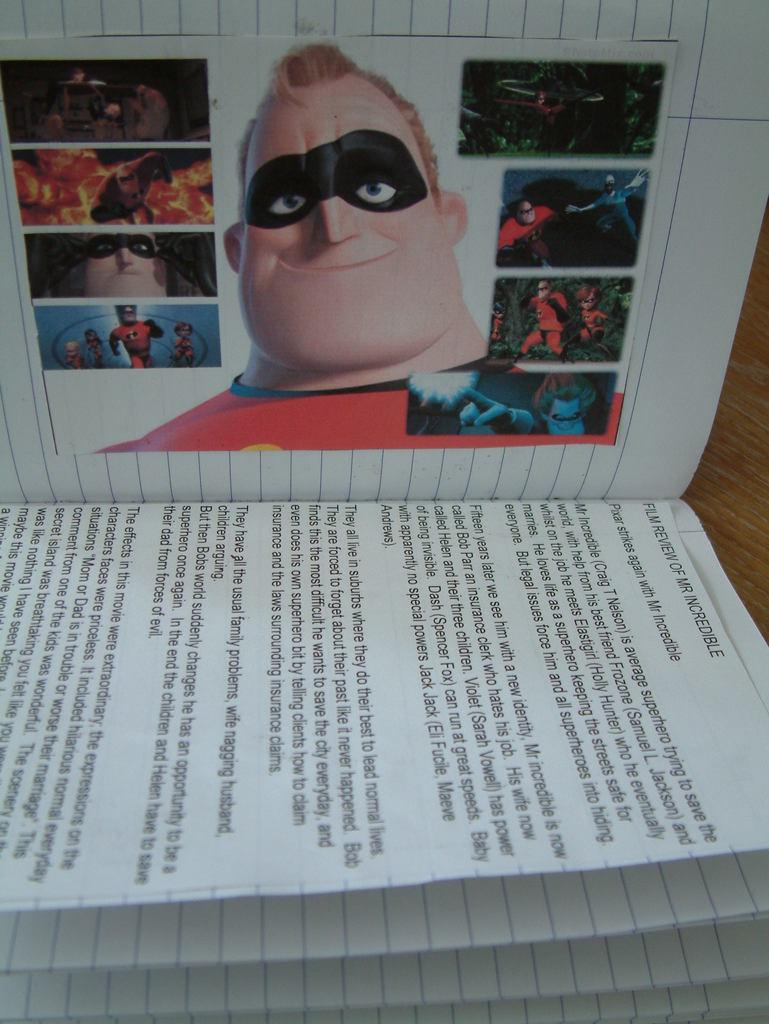What is present in the image? There is a book in the image. What type of content does the book contain? The book contains pictures of superheroes. Where is the pail located in the image? There is no pail present in the image. What type of work environment is depicted in the image? The image does not depict an office or any work environment; it only shows a book with pictures of superheroes. 